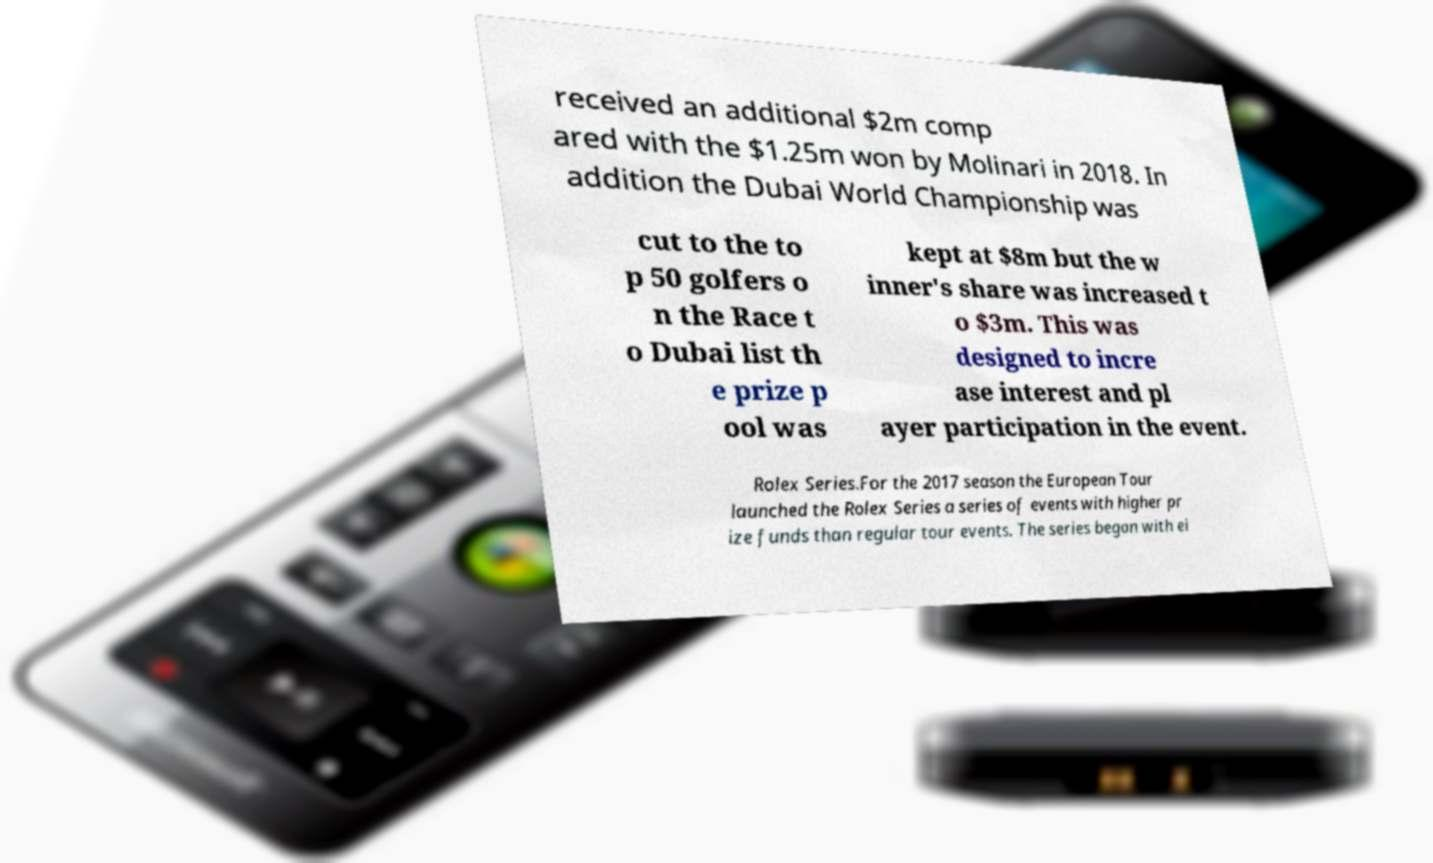For documentation purposes, I need the text within this image transcribed. Could you provide that? received an additional $2m comp ared with the $1.25m won by Molinari in 2018. In addition the Dubai World Championship was cut to the to p 50 golfers o n the Race t o Dubai list th e prize p ool was kept at $8m but the w inner's share was increased t o $3m. This was designed to incre ase interest and pl ayer participation in the event. Rolex Series.For the 2017 season the European Tour launched the Rolex Series a series of events with higher pr ize funds than regular tour events. The series began with ei 